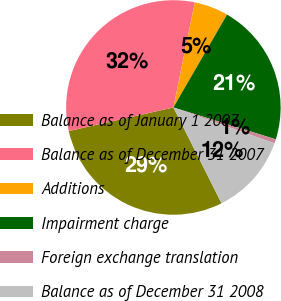<chart> <loc_0><loc_0><loc_500><loc_500><pie_chart><fcel>Balance as of January 1 2007<fcel>Balance as of December 31 2007<fcel>Additions<fcel>Impairment charge<fcel>Foreign exchange translation<fcel>Balance as of December 31 2008<nl><fcel>28.88%<fcel>31.73%<fcel>5.14%<fcel>21.46%<fcel>0.63%<fcel>12.16%<nl></chart> 